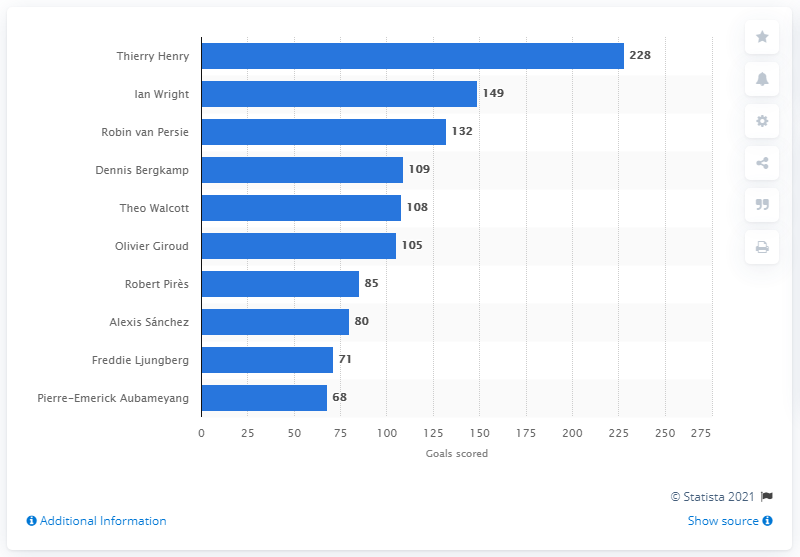Mention a couple of crucial points in this snapshot. As of July 2020, Thierry Henry was the leading goal scorer for Arsenal FC. Ian Wright scored a total of 149 goals. 